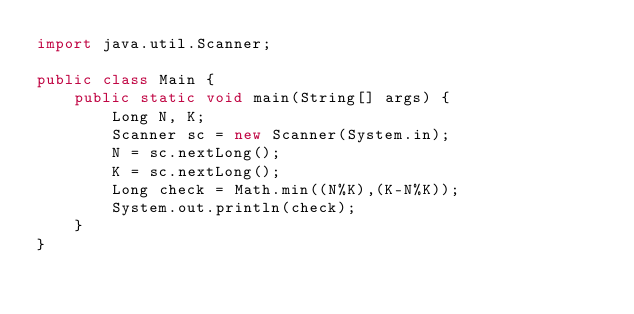Convert code to text. <code><loc_0><loc_0><loc_500><loc_500><_Java_>import java.util.Scanner;

public class Main {
    public static void main(String[] args) {
        Long N, K;
        Scanner sc = new Scanner(System.in);
        N = sc.nextLong();
        K = sc.nextLong();
        Long check = Math.min((N%K),(K-N%K));
        System.out.println(check);
    }
}
</code> 